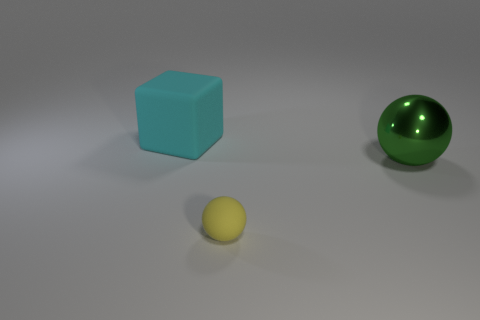Add 1 purple rubber things. How many objects exist? 4 Subtract all spheres. How many objects are left? 1 Add 3 small yellow matte spheres. How many small yellow matte spheres are left? 4 Add 2 big green shiny things. How many big green shiny things exist? 3 Subtract 0 purple cubes. How many objects are left? 3 Subtract all large rubber objects. Subtract all green objects. How many objects are left? 1 